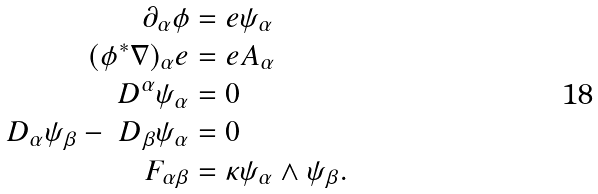<formula> <loc_0><loc_0><loc_500><loc_500>\partial _ { \alpha } \phi & = e \psi _ { \alpha } \\ ( \phi ^ { * } \nabla ) _ { \alpha } e & = e A _ { \alpha } \\ \ D ^ { \alpha } \psi _ { \alpha } & = 0 \\ \ D _ { \alpha } \psi _ { \beta } - \ D _ { \beta } \psi _ { \alpha } & = 0 \\ F _ { \alpha \beta } & = \kappa \psi _ { \alpha } \wedge \psi _ { \beta } .</formula> 